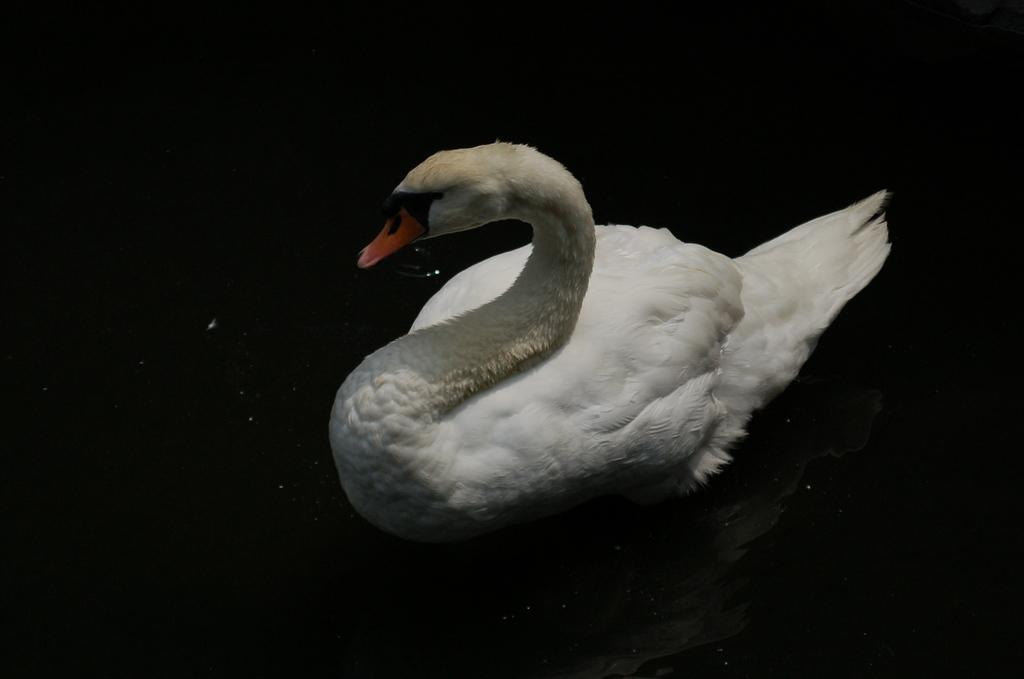What animal is present in the image? There is a duck in the image. What is the color of the duck? The duck is white in color. What can be observed about the background of the image? The background of the image is dark. What hobbies does the bee have in the image? There is no bee present in the image, so it is not possible to determine its hobbies. 